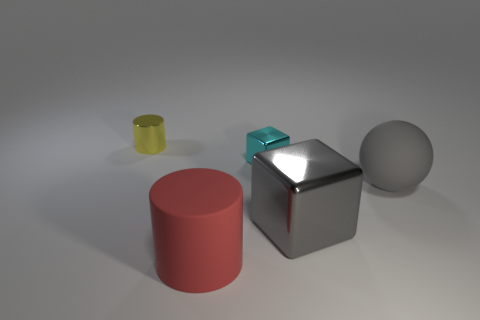How many gray metal objects have the same shape as the small yellow object?
Your answer should be compact. 0. There is a large sphere that is the same color as the large shiny block; what material is it?
Give a very brief answer. Rubber. What number of objects are big blue rubber spheres or objects behind the gray rubber thing?
Offer a terse response. 2. What is the material of the large red cylinder?
Provide a succinct answer. Rubber. There is a yellow thing that is the same shape as the large red rubber thing; what is its material?
Your answer should be compact. Metal. There is a cylinder that is left of the cylinder on the right side of the yellow shiny cylinder; what color is it?
Your answer should be very brief. Yellow. What number of metallic things are red cylinders or tiny gray cylinders?
Make the answer very short. 0. Do the big cylinder and the yellow cylinder have the same material?
Offer a very short reply. No. There is a tiny thing that is to the right of the big matte object that is left of the matte sphere; what is its material?
Provide a succinct answer. Metal. How many big things are either red objects or blocks?
Your answer should be very brief. 2. 